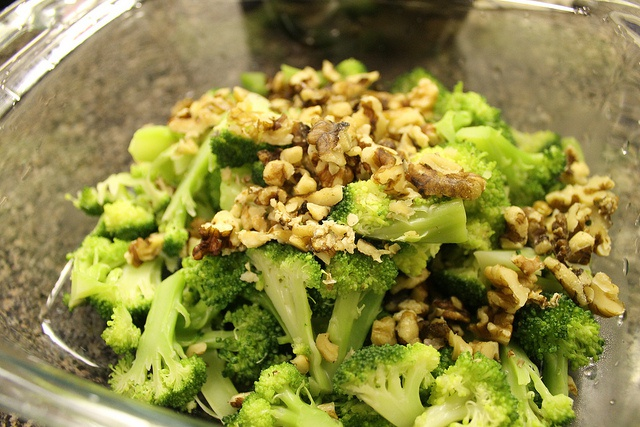Describe the objects in this image and their specific colors. I can see broccoli in black, khaki, and olive tones and broccoli in black and olive tones in this image. 